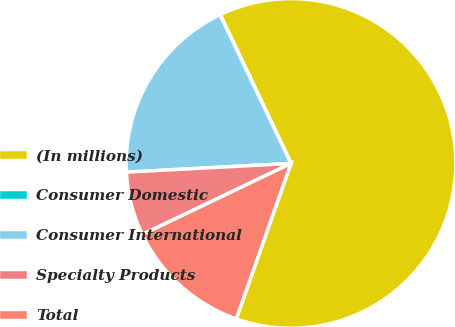Convert chart. <chart><loc_0><loc_0><loc_500><loc_500><pie_chart><fcel>(In millions)<fcel>Consumer Domestic<fcel>Consumer International<fcel>Specialty Products<fcel>Total<nl><fcel>62.46%<fcel>0.02%<fcel>18.75%<fcel>6.26%<fcel>12.51%<nl></chart> 